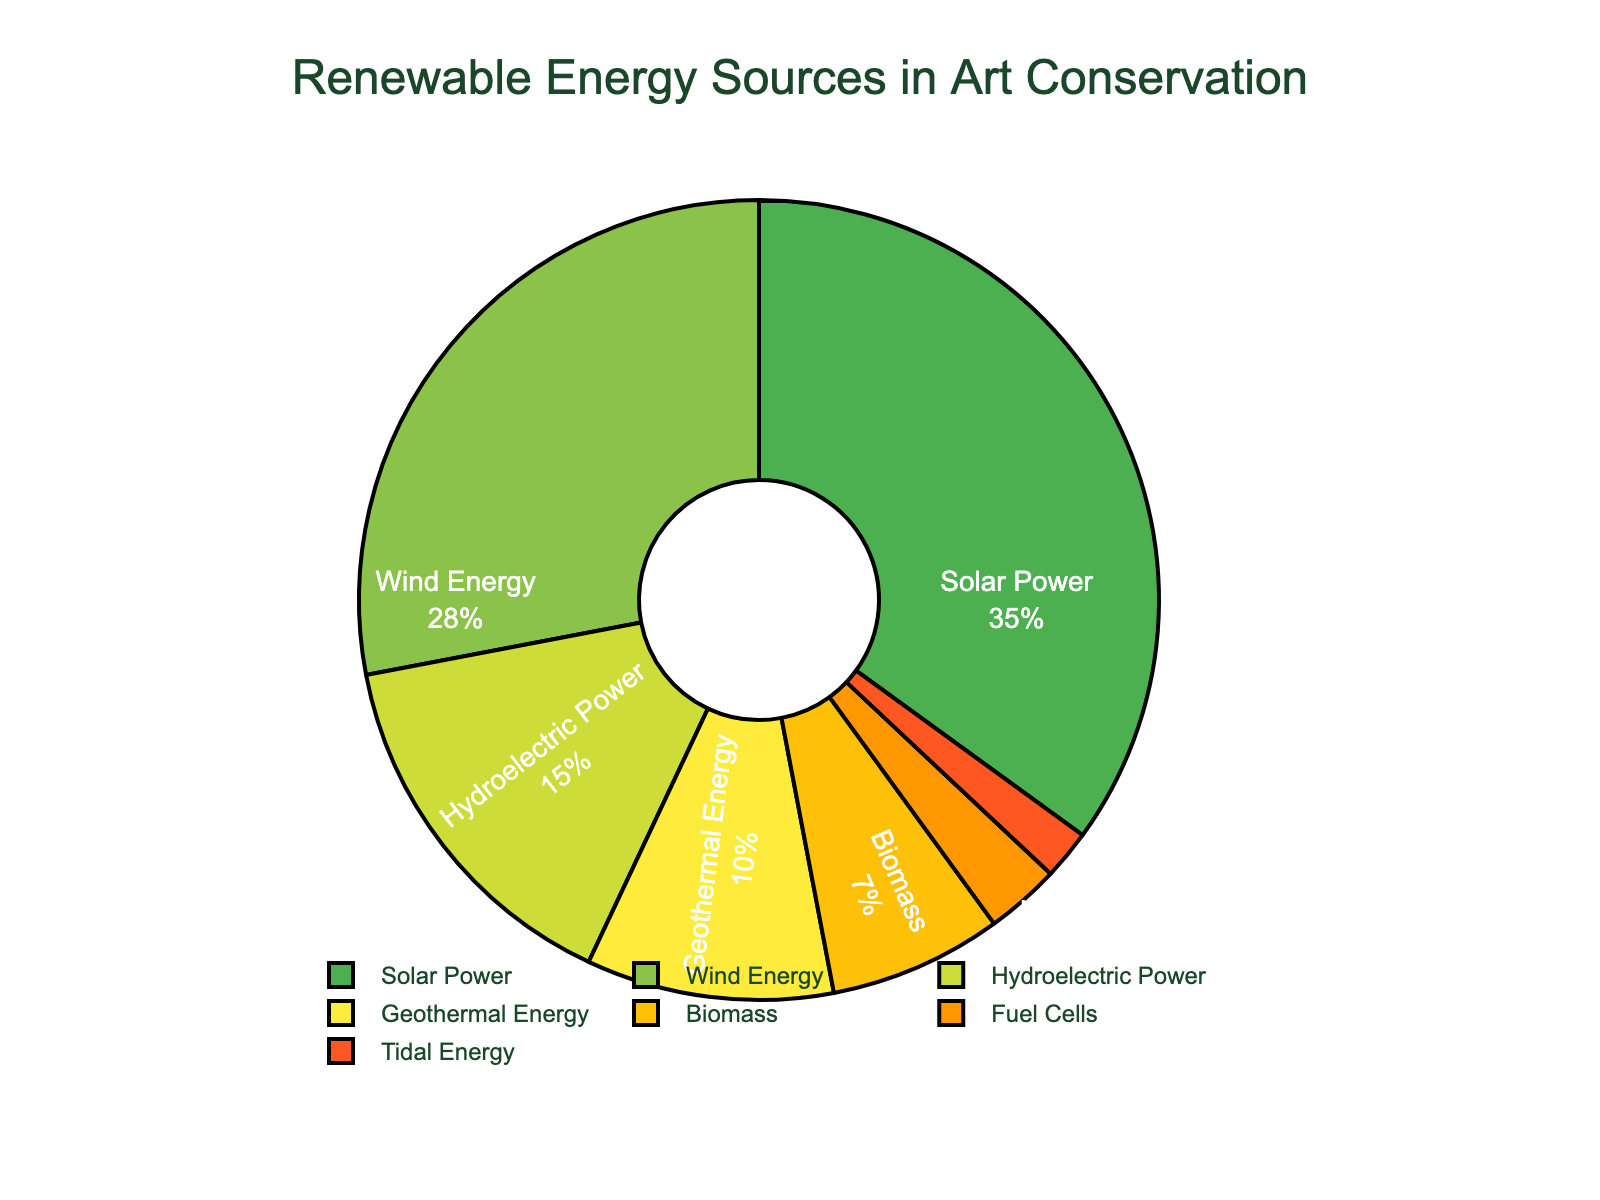what percentage of renewable energy sources used is from Wind Energy? The pie chart shows the percentage breakdown of renewable energy sources. To find the percentage for Wind Energy, locate the part labeled Wind Energy and read the corresponding percentage value.
Answer: 28 Which energy source has the smallest contribution? The pie chart lists several types of renewable energy sources with their respective percentages. The smallest percentage corresponds to Tidal Energy.
Answer: Tidal Energy What is the combined percentage of Hydroelectric Power and Biomass? The pie chart provides the percentages for individual sources. Sum up the percentages of Hydroelectric Power (15) and Biomass (7). Thus, the combined percentage is 15 + 7.
Answer: 22 Which energy source contributes more, Solar Power or Geothermal Energy, and by how much? The graph provides the percentages for both Solar Power and Geothermal Energy. Subtract the percentage of Geothermal Energy (10) from Solar Power (35) to find the difference. Therefore, Solar Power contributes 35 - 10 more.
Answer: 25 Is the percentage of Solar Power greater than that of Wind Energy and Hydroelectric Power combined? Calculate the combined percentage of Wind Energy (28) and Hydroelectric Power (15), which totals 28 + 15 = 43. Compare this with the percentage of Solar Power, which is 35. Solar Power (35) is less than the combined percentage of Wind Energy and Hydroelectric Power (43).
Answer: No Which energy source is represented by the second largest segment in the pie chart? Analyze the segments in the pie chart to identify the energy sources and their corresponding sizes. The second largest segment represents Wind Energy with 28%.
Answer: Wind Energy How many different renewable energy sources contribute less than 10% each? Identify sections contributing less than 10%: Geothermal Energy (10%), Biomass (7%), Fuel Cells (3%), and Tidal Energy (2%). There are three sources below this threshold: Biomass, Fuel Cells, and Tidal Energy.
Answer: 3 What color is the segment representing Biomass energy? Observing the pie chart, the segment for Biomass is colored to distinguish it from others. The Biomass segment is in orange.
Answer: Orange If we were to focus on the top three renewable energy sources, what would their combined percentage be? Identify the top three sources: Solar Power (35), Wind Energy (28), Hydroelectric Power (15). Summing these percentages, 35+28+15 equals 78.
Answer: 78 